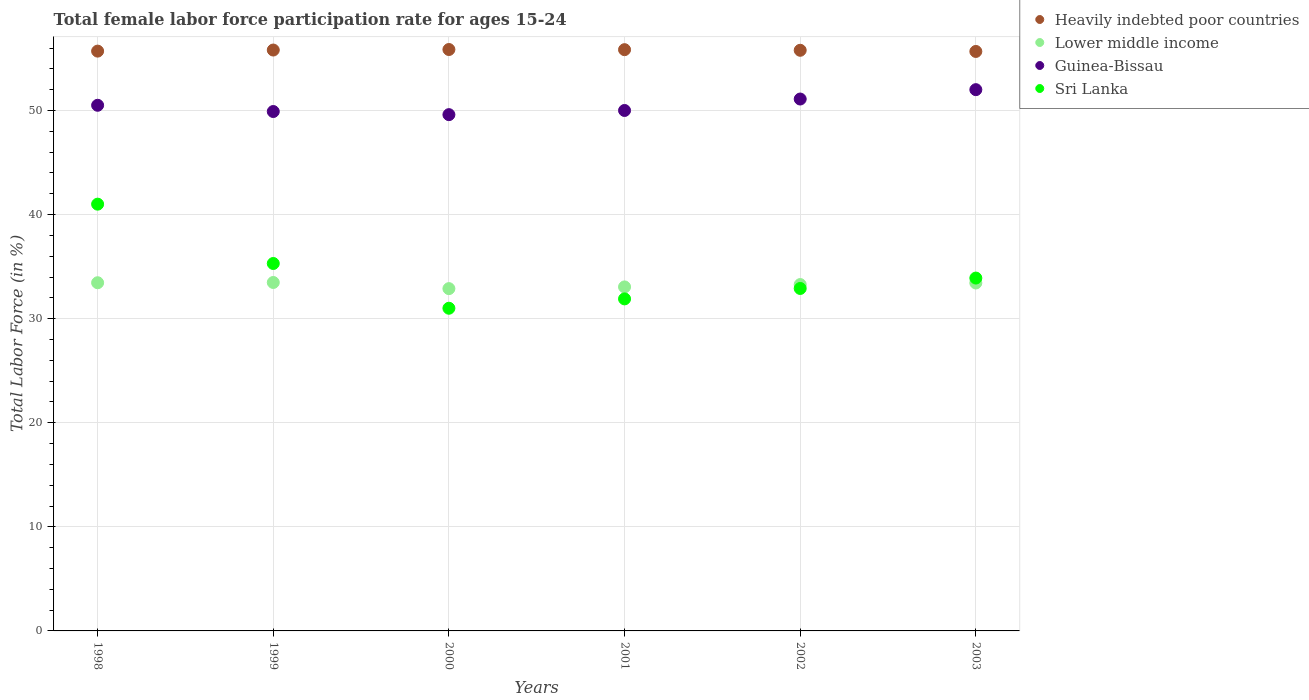Is the number of dotlines equal to the number of legend labels?
Your answer should be compact. Yes. Across all years, what is the maximum female labor force participation rate in Sri Lanka?
Your answer should be very brief. 41. Across all years, what is the minimum female labor force participation rate in Heavily indebted poor countries?
Your answer should be compact. 55.67. What is the total female labor force participation rate in Heavily indebted poor countries in the graph?
Make the answer very short. 334.66. What is the difference between the female labor force participation rate in Guinea-Bissau in 2000 and that in 2003?
Your response must be concise. -2.4. What is the difference between the female labor force participation rate in Sri Lanka in 1998 and the female labor force participation rate in Lower middle income in 2002?
Provide a short and direct response. 7.72. What is the average female labor force participation rate in Guinea-Bissau per year?
Offer a terse response. 50.52. In the year 2002, what is the difference between the female labor force participation rate in Guinea-Bissau and female labor force participation rate in Heavily indebted poor countries?
Offer a terse response. -4.68. In how many years, is the female labor force participation rate in Lower middle income greater than 52 %?
Provide a succinct answer. 0. What is the ratio of the female labor force participation rate in Sri Lanka in 1998 to that in 2001?
Make the answer very short. 1.29. Is the female labor force participation rate in Heavily indebted poor countries in 1998 less than that in 2000?
Provide a short and direct response. Yes. Is the difference between the female labor force participation rate in Guinea-Bissau in 1999 and 2003 greater than the difference between the female labor force participation rate in Heavily indebted poor countries in 1999 and 2003?
Ensure brevity in your answer.  No. What is the difference between the highest and the second highest female labor force participation rate in Heavily indebted poor countries?
Provide a succinct answer. 0.02. In how many years, is the female labor force participation rate in Guinea-Bissau greater than the average female labor force participation rate in Guinea-Bissau taken over all years?
Provide a short and direct response. 2. Is it the case that in every year, the sum of the female labor force participation rate in Lower middle income and female labor force participation rate in Sri Lanka  is greater than the female labor force participation rate in Guinea-Bissau?
Your answer should be very brief. Yes. Does the female labor force participation rate in Guinea-Bissau monotonically increase over the years?
Make the answer very short. No. Are the values on the major ticks of Y-axis written in scientific E-notation?
Provide a short and direct response. No. Does the graph contain grids?
Give a very brief answer. Yes. What is the title of the graph?
Offer a terse response. Total female labor force participation rate for ages 15-24. Does "Denmark" appear as one of the legend labels in the graph?
Your answer should be very brief. No. What is the label or title of the X-axis?
Offer a terse response. Years. What is the Total Labor Force (in %) of Heavily indebted poor countries in 1998?
Offer a terse response. 55.7. What is the Total Labor Force (in %) of Lower middle income in 1998?
Make the answer very short. 33.45. What is the Total Labor Force (in %) of Guinea-Bissau in 1998?
Keep it short and to the point. 50.5. What is the Total Labor Force (in %) of Sri Lanka in 1998?
Your response must be concise. 41. What is the Total Labor Force (in %) in Heavily indebted poor countries in 1999?
Ensure brevity in your answer.  55.81. What is the Total Labor Force (in %) of Lower middle income in 1999?
Offer a very short reply. 33.48. What is the Total Labor Force (in %) in Guinea-Bissau in 1999?
Your answer should be compact. 49.9. What is the Total Labor Force (in %) in Sri Lanka in 1999?
Offer a very short reply. 35.3. What is the Total Labor Force (in %) in Heavily indebted poor countries in 2000?
Make the answer very short. 55.86. What is the Total Labor Force (in %) in Lower middle income in 2000?
Keep it short and to the point. 32.89. What is the Total Labor Force (in %) of Guinea-Bissau in 2000?
Keep it short and to the point. 49.6. What is the Total Labor Force (in %) of Heavily indebted poor countries in 2001?
Offer a very short reply. 55.84. What is the Total Labor Force (in %) of Lower middle income in 2001?
Give a very brief answer. 33.05. What is the Total Labor Force (in %) of Sri Lanka in 2001?
Your response must be concise. 31.9. What is the Total Labor Force (in %) in Heavily indebted poor countries in 2002?
Your response must be concise. 55.78. What is the Total Labor Force (in %) of Lower middle income in 2002?
Provide a short and direct response. 33.28. What is the Total Labor Force (in %) of Guinea-Bissau in 2002?
Keep it short and to the point. 51.1. What is the Total Labor Force (in %) of Sri Lanka in 2002?
Make the answer very short. 32.9. What is the Total Labor Force (in %) in Heavily indebted poor countries in 2003?
Offer a very short reply. 55.67. What is the Total Labor Force (in %) of Lower middle income in 2003?
Offer a very short reply. 33.43. What is the Total Labor Force (in %) of Sri Lanka in 2003?
Provide a succinct answer. 33.9. Across all years, what is the maximum Total Labor Force (in %) of Heavily indebted poor countries?
Keep it short and to the point. 55.86. Across all years, what is the maximum Total Labor Force (in %) of Lower middle income?
Your answer should be very brief. 33.48. Across all years, what is the minimum Total Labor Force (in %) in Heavily indebted poor countries?
Give a very brief answer. 55.67. Across all years, what is the minimum Total Labor Force (in %) in Lower middle income?
Your answer should be very brief. 32.89. Across all years, what is the minimum Total Labor Force (in %) of Guinea-Bissau?
Ensure brevity in your answer.  49.6. What is the total Total Labor Force (in %) in Heavily indebted poor countries in the graph?
Your answer should be compact. 334.66. What is the total Total Labor Force (in %) in Lower middle income in the graph?
Make the answer very short. 199.56. What is the total Total Labor Force (in %) in Guinea-Bissau in the graph?
Your answer should be very brief. 303.1. What is the total Total Labor Force (in %) of Sri Lanka in the graph?
Make the answer very short. 206. What is the difference between the Total Labor Force (in %) of Heavily indebted poor countries in 1998 and that in 1999?
Your answer should be compact. -0.1. What is the difference between the Total Labor Force (in %) of Lower middle income in 1998 and that in 1999?
Your answer should be very brief. -0.02. What is the difference between the Total Labor Force (in %) of Sri Lanka in 1998 and that in 1999?
Give a very brief answer. 5.7. What is the difference between the Total Labor Force (in %) of Heavily indebted poor countries in 1998 and that in 2000?
Provide a succinct answer. -0.15. What is the difference between the Total Labor Force (in %) in Lower middle income in 1998 and that in 2000?
Your response must be concise. 0.56. What is the difference between the Total Labor Force (in %) of Sri Lanka in 1998 and that in 2000?
Your answer should be compact. 10. What is the difference between the Total Labor Force (in %) in Heavily indebted poor countries in 1998 and that in 2001?
Provide a succinct answer. -0.14. What is the difference between the Total Labor Force (in %) of Lower middle income in 1998 and that in 2001?
Your answer should be very brief. 0.4. What is the difference between the Total Labor Force (in %) of Heavily indebted poor countries in 1998 and that in 2002?
Ensure brevity in your answer.  -0.08. What is the difference between the Total Labor Force (in %) in Lower middle income in 1998 and that in 2002?
Your response must be concise. 0.17. What is the difference between the Total Labor Force (in %) in Sri Lanka in 1998 and that in 2002?
Keep it short and to the point. 8.1. What is the difference between the Total Labor Force (in %) in Heavily indebted poor countries in 1998 and that in 2003?
Offer a very short reply. 0.03. What is the difference between the Total Labor Force (in %) of Lower middle income in 1998 and that in 2003?
Offer a very short reply. 0.02. What is the difference between the Total Labor Force (in %) of Guinea-Bissau in 1998 and that in 2003?
Your answer should be very brief. -1.5. What is the difference between the Total Labor Force (in %) in Sri Lanka in 1998 and that in 2003?
Make the answer very short. 7.1. What is the difference between the Total Labor Force (in %) of Heavily indebted poor countries in 1999 and that in 2000?
Your answer should be very brief. -0.05. What is the difference between the Total Labor Force (in %) in Lower middle income in 1999 and that in 2000?
Your answer should be very brief. 0.59. What is the difference between the Total Labor Force (in %) of Heavily indebted poor countries in 1999 and that in 2001?
Give a very brief answer. -0.04. What is the difference between the Total Labor Force (in %) in Lower middle income in 1999 and that in 2001?
Offer a very short reply. 0.43. What is the difference between the Total Labor Force (in %) of Guinea-Bissau in 1999 and that in 2001?
Your answer should be compact. -0.1. What is the difference between the Total Labor Force (in %) in Heavily indebted poor countries in 1999 and that in 2002?
Your response must be concise. 0.02. What is the difference between the Total Labor Force (in %) of Lower middle income in 1999 and that in 2002?
Provide a succinct answer. 0.2. What is the difference between the Total Labor Force (in %) in Heavily indebted poor countries in 1999 and that in 2003?
Give a very brief answer. 0.14. What is the difference between the Total Labor Force (in %) of Lower middle income in 1999 and that in 2003?
Your answer should be compact. 0.05. What is the difference between the Total Labor Force (in %) in Guinea-Bissau in 1999 and that in 2003?
Keep it short and to the point. -2.1. What is the difference between the Total Labor Force (in %) in Heavily indebted poor countries in 2000 and that in 2001?
Give a very brief answer. 0.02. What is the difference between the Total Labor Force (in %) of Lower middle income in 2000 and that in 2001?
Ensure brevity in your answer.  -0.16. What is the difference between the Total Labor Force (in %) of Guinea-Bissau in 2000 and that in 2001?
Your response must be concise. -0.4. What is the difference between the Total Labor Force (in %) of Heavily indebted poor countries in 2000 and that in 2002?
Ensure brevity in your answer.  0.07. What is the difference between the Total Labor Force (in %) in Lower middle income in 2000 and that in 2002?
Make the answer very short. -0.39. What is the difference between the Total Labor Force (in %) in Heavily indebted poor countries in 2000 and that in 2003?
Provide a succinct answer. 0.19. What is the difference between the Total Labor Force (in %) of Lower middle income in 2000 and that in 2003?
Ensure brevity in your answer.  -0.54. What is the difference between the Total Labor Force (in %) in Heavily indebted poor countries in 2001 and that in 2002?
Give a very brief answer. 0.06. What is the difference between the Total Labor Force (in %) of Lower middle income in 2001 and that in 2002?
Give a very brief answer. -0.23. What is the difference between the Total Labor Force (in %) in Guinea-Bissau in 2001 and that in 2002?
Your response must be concise. -1.1. What is the difference between the Total Labor Force (in %) of Sri Lanka in 2001 and that in 2002?
Make the answer very short. -1. What is the difference between the Total Labor Force (in %) of Heavily indebted poor countries in 2001 and that in 2003?
Ensure brevity in your answer.  0.17. What is the difference between the Total Labor Force (in %) of Lower middle income in 2001 and that in 2003?
Provide a short and direct response. -0.38. What is the difference between the Total Labor Force (in %) in Heavily indebted poor countries in 2002 and that in 2003?
Your answer should be very brief. 0.11. What is the difference between the Total Labor Force (in %) in Lower middle income in 2002 and that in 2003?
Provide a succinct answer. -0.15. What is the difference between the Total Labor Force (in %) in Heavily indebted poor countries in 1998 and the Total Labor Force (in %) in Lower middle income in 1999?
Give a very brief answer. 22.23. What is the difference between the Total Labor Force (in %) in Heavily indebted poor countries in 1998 and the Total Labor Force (in %) in Guinea-Bissau in 1999?
Give a very brief answer. 5.8. What is the difference between the Total Labor Force (in %) of Heavily indebted poor countries in 1998 and the Total Labor Force (in %) of Sri Lanka in 1999?
Keep it short and to the point. 20.4. What is the difference between the Total Labor Force (in %) in Lower middle income in 1998 and the Total Labor Force (in %) in Guinea-Bissau in 1999?
Your response must be concise. -16.45. What is the difference between the Total Labor Force (in %) in Lower middle income in 1998 and the Total Labor Force (in %) in Sri Lanka in 1999?
Provide a succinct answer. -1.85. What is the difference between the Total Labor Force (in %) in Heavily indebted poor countries in 1998 and the Total Labor Force (in %) in Lower middle income in 2000?
Give a very brief answer. 22.82. What is the difference between the Total Labor Force (in %) in Heavily indebted poor countries in 1998 and the Total Labor Force (in %) in Guinea-Bissau in 2000?
Offer a terse response. 6.1. What is the difference between the Total Labor Force (in %) of Heavily indebted poor countries in 1998 and the Total Labor Force (in %) of Sri Lanka in 2000?
Offer a very short reply. 24.7. What is the difference between the Total Labor Force (in %) in Lower middle income in 1998 and the Total Labor Force (in %) in Guinea-Bissau in 2000?
Your answer should be compact. -16.15. What is the difference between the Total Labor Force (in %) of Lower middle income in 1998 and the Total Labor Force (in %) of Sri Lanka in 2000?
Offer a very short reply. 2.45. What is the difference between the Total Labor Force (in %) in Heavily indebted poor countries in 1998 and the Total Labor Force (in %) in Lower middle income in 2001?
Provide a succinct answer. 22.65. What is the difference between the Total Labor Force (in %) in Heavily indebted poor countries in 1998 and the Total Labor Force (in %) in Guinea-Bissau in 2001?
Your answer should be compact. 5.7. What is the difference between the Total Labor Force (in %) of Heavily indebted poor countries in 1998 and the Total Labor Force (in %) of Sri Lanka in 2001?
Your response must be concise. 23.8. What is the difference between the Total Labor Force (in %) of Lower middle income in 1998 and the Total Labor Force (in %) of Guinea-Bissau in 2001?
Offer a very short reply. -16.55. What is the difference between the Total Labor Force (in %) in Lower middle income in 1998 and the Total Labor Force (in %) in Sri Lanka in 2001?
Provide a succinct answer. 1.55. What is the difference between the Total Labor Force (in %) of Guinea-Bissau in 1998 and the Total Labor Force (in %) of Sri Lanka in 2001?
Your answer should be compact. 18.6. What is the difference between the Total Labor Force (in %) of Heavily indebted poor countries in 1998 and the Total Labor Force (in %) of Lower middle income in 2002?
Offer a very short reply. 22.43. What is the difference between the Total Labor Force (in %) of Heavily indebted poor countries in 1998 and the Total Labor Force (in %) of Guinea-Bissau in 2002?
Provide a short and direct response. 4.6. What is the difference between the Total Labor Force (in %) in Heavily indebted poor countries in 1998 and the Total Labor Force (in %) in Sri Lanka in 2002?
Offer a terse response. 22.8. What is the difference between the Total Labor Force (in %) of Lower middle income in 1998 and the Total Labor Force (in %) of Guinea-Bissau in 2002?
Keep it short and to the point. -17.65. What is the difference between the Total Labor Force (in %) of Lower middle income in 1998 and the Total Labor Force (in %) of Sri Lanka in 2002?
Provide a succinct answer. 0.55. What is the difference between the Total Labor Force (in %) in Heavily indebted poor countries in 1998 and the Total Labor Force (in %) in Lower middle income in 2003?
Make the answer very short. 22.27. What is the difference between the Total Labor Force (in %) in Heavily indebted poor countries in 1998 and the Total Labor Force (in %) in Guinea-Bissau in 2003?
Make the answer very short. 3.7. What is the difference between the Total Labor Force (in %) of Heavily indebted poor countries in 1998 and the Total Labor Force (in %) of Sri Lanka in 2003?
Provide a succinct answer. 21.8. What is the difference between the Total Labor Force (in %) of Lower middle income in 1998 and the Total Labor Force (in %) of Guinea-Bissau in 2003?
Provide a short and direct response. -18.55. What is the difference between the Total Labor Force (in %) in Lower middle income in 1998 and the Total Labor Force (in %) in Sri Lanka in 2003?
Provide a succinct answer. -0.45. What is the difference between the Total Labor Force (in %) of Guinea-Bissau in 1998 and the Total Labor Force (in %) of Sri Lanka in 2003?
Provide a succinct answer. 16.6. What is the difference between the Total Labor Force (in %) of Heavily indebted poor countries in 1999 and the Total Labor Force (in %) of Lower middle income in 2000?
Offer a very short reply. 22.92. What is the difference between the Total Labor Force (in %) of Heavily indebted poor countries in 1999 and the Total Labor Force (in %) of Guinea-Bissau in 2000?
Provide a succinct answer. 6.21. What is the difference between the Total Labor Force (in %) of Heavily indebted poor countries in 1999 and the Total Labor Force (in %) of Sri Lanka in 2000?
Provide a succinct answer. 24.81. What is the difference between the Total Labor Force (in %) in Lower middle income in 1999 and the Total Labor Force (in %) in Guinea-Bissau in 2000?
Provide a short and direct response. -16.12. What is the difference between the Total Labor Force (in %) of Lower middle income in 1999 and the Total Labor Force (in %) of Sri Lanka in 2000?
Ensure brevity in your answer.  2.48. What is the difference between the Total Labor Force (in %) of Heavily indebted poor countries in 1999 and the Total Labor Force (in %) of Lower middle income in 2001?
Make the answer very short. 22.76. What is the difference between the Total Labor Force (in %) in Heavily indebted poor countries in 1999 and the Total Labor Force (in %) in Guinea-Bissau in 2001?
Offer a terse response. 5.81. What is the difference between the Total Labor Force (in %) in Heavily indebted poor countries in 1999 and the Total Labor Force (in %) in Sri Lanka in 2001?
Your answer should be compact. 23.91. What is the difference between the Total Labor Force (in %) of Lower middle income in 1999 and the Total Labor Force (in %) of Guinea-Bissau in 2001?
Your answer should be compact. -16.52. What is the difference between the Total Labor Force (in %) of Lower middle income in 1999 and the Total Labor Force (in %) of Sri Lanka in 2001?
Make the answer very short. 1.58. What is the difference between the Total Labor Force (in %) of Heavily indebted poor countries in 1999 and the Total Labor Force (in %) of Lower middle income in 2002?
Ensure brevity in your answer.  22.53. What is the difference between the Total Labor Force (in %) of Heavily indebted poor countries in 1999 and the Total Labor Force (in %) of Guinea-Bissau in 2002?
Ensure brevity in your answer.  4.71. What is the difference between the Total Labor Force (in %) of Heavily indebted poor countries in 1999 and the Total Labor Force (in %) of Sri Lanka in 2002?
Keep it short and to the point. 22.91. What is the difference between the Total Labor Force (in %) of Lower middle income in 1999 and the Total Labor Force (in %) of Guinea-Bissau in 2002?
Your response must be concise. -17.62. What is the difference between the Total Labor Force (in %) in Lower middle income in 1999 and the Total Labor Force (in %) in Sri Lanka in 2002?
Offer a terse response. 0.58. What is the difference between the Total Labor Force (in %) in Heavily indebted poor countries in 1999 and the Total Labor Force (in %) in Lower middle income in 2003?
Your answer should be very brief. 22.38. What is the difference between the Total Labor Force (in %) of Heavily indebted poor countries in 1999 and the Total Labor Force (in %) of Guinea-Bissau in 2003?
Give a very brief answer. 3.81. What is the difference between the Total Labor Force (in %) in Heavily indebted poor countries in 1999 and the Total Labor Force (in %) in Sri Lanka in 2003?
Ensure brevity in your answer.  21.91. What is the difference between the Total Labor Force (in %) of Lower middle income in 1999 and the Total Labor Force (in %) of Guinea-Bissau in 2003?
Your response must be concise. -18.52. What is the difference between the Total Labor Force (in %) in Lower middle income in 1999 and the Total Labor Force (in %) in Sri Lanka in 2003?
Keep it short and to the point. -0.42. What is the difference between the Total Labor Force (in %) in Heavily indebted poor countries in 2000 and the Total Labor Force (in %) in Lower middle income in 2001?
Your answer should be very brief. 22.81. What is the difference between the Total Labor Force (in %) in Heavily indebted poor countries in 2000 and the Total Labor Force (in %) in Guinea-Bissau in 2001?
Offer a terse response. 5.86. What is the difference between the Total Labor Force (in %) in Heavily indebted poor countries in 2000 and the Total Labor Force (in %) in Sri Lanka in 2001?
Your response must be concise. 23.96. What is the difference between the Total Labor Force (in %) of Lower middle income in 2000 and the Total Labor Force (in %) of Guinea-Bissau in 2001?
Provide a short and direct response. -17.11. What is the difference between the Total Labor Force (in %) of Lower middle income in 2000 and the Total Labor Force (in %) of Sri Lanka in 2001?
Make the answer very short. 0.99. What is the difference between the Total Labor Force (in %) in Guinea-Bissau in 2000 and the Total Labor Force (in %) in Sri Lanka in 2001?
Ensure brevity in your answer.  17.7. What is the difference between the Total Labor Force (in %) in Heavily indebted poor countries in 2000 and the Total Labor Force (in %) in Lower middle income in 2002?
Give a very brief answer. 22.58. What is the difference between the Total Labor Force (in %) of Heavily indebted poor countries in 2000 and the Total Labor Force (in %) of Guinea-Bissau in 2002?
Keep it short and to the point. 4.76. What is the difference between the Total Labor Force (in %) in Heavily indebted poor countries in 2000 and the Total Labor Force (in %) in Sri Lanka in 2002?
Your answer should be very brief. 22.96. What is the difference between the Total Labor Force (in %) of Lower middle income in 2000 and the Total Labor Force (in %) of Guinea-Bissau in 2002?
Provide a short and direct response. -18.21. What is the difference between the Total Labor Force (in %) of Lower middle income in 2000 and the Total Labor Force (in %) of Sri Lanka in 2002?
Your response must be concise. -0.01. What is the difference between the Total Labor Force (in %) of Guinea-Bissau in 2000 and the Total Labor Force (in %) of Sri Lanka in 2002?
Keep it short and to the point. 16.7. What is the difference between the Total Labor Force (in %) in Heavily indebted poor countries in 2000 and the Total Labor Force (in %) in Lower middle income in 2003?
Offer a terse response. 22.43. What is the difference between the Total Labor Force (in %) in Heavily indebted poor countries in 2000 and the Total Labor Force (in %) in Guinea-Bissau in 2003?
Provide a succinct answer. 3.86. What is the difference between the Total Labor Force (in %) in Heavily indebted poor countries in 2000 and the Total Labor Force (in %) in Sri Lanka in 2003?
Ensure brevity in your answer.  21.96. What is the difference between the Total Labor Force (in %) in Lower middle income in 2000 and the Total Labor Force (in %) in Guinea-Bissau in 2003?
Provide a succinct answer. -19.11. What is the difference between the Total Labor Force (in %) in Lower middle income in 2000 and the Total Labor Force (in %) in Sri Lanka in 2003?
Offer a terse response. -1.01. What is the difference between the Total Labor Force (in %) of Heavily indebted poor countries in 2001 and the Total Labor Force (in %) of Lower middle income in 2002?
Make the answer very short. 22.57. What is the difference between the Total Labor Force (in %) of Heavily indebted poor countries in 2001 and the Total Labor Force (in %) of Guinea-Bissau in 2002?
Provide a short and direct response. 4.74. What is the difference between the Total Labor Force (in %) in Heavily indebted poor countries in 2001 and the Total Labor Force (in %) in Sri Lanka in 2002?
Your answer should be very brief. 22.94. What is the difference between the Total Labor Force (in %) of Lower middle income in 2001 and the Total Labor Force (in %) of Guinea-Bissau in 2002?
Offer a terse response. -18.05. What is the difference between the Total Labor Force (in %) of Lower middle income in 2001 and the Total Labor Force (in %) of Sri Lanka in 2002?
Make the answer very short. 0.15. What is the difference between the Total Labor Force (in %) in Heavily indebted poor countries in 2001 and the Total Labor Force (in %) in Lower middle income in 2003?
Ensure brevity in your answer.  22.41. What is the difference between the Total Labor Force (in %) of Heavily indebted poor countries in 2001 and the Total Labor Force (in %) of Guinea-Bissau in 2003?
Your answer should be compact. 3.84. What is the difference between the Total Labor Force (in %) of Heavily indebted poor countries in 2001 and the Total Labor Force (in %) of Sri Lanka in 2003?
Your answer should be compact. 21.94. What is the difference between the Total Labor Force (in %) of Lower middle income in 2001 and the Total Labor Force (in %) of Guinea-Bissau in 2003?
Provide a short and direct response. -18.95. What is the difference between the Total Labor Force (in %) in Lower middle income in 2001 and the Total Labor Force (in %) in Sri Lanka in 2003?
Keep it short and to the point. -0.85. What is the difference between the Total Labor Force (in %) of Heavily indebted poor countries in 2002 and the Total Labor Force (in %) of Lower middle income in 2003?
Your response must be concise. 22.35. What is the difference between the Total Labor Force (in %) in Heavily indebted poor countries in 2002 and the Total Labor Force (in %) in Guinea-Bissau in 2003?
Offer a very short reply. 3.78. What is the difference between the Total Labor Force (in %) in Heavily indebted poor countries in 2002 and the Total Labor Force (in %) in Sri Lanka in 2003?
Offer a terse response. 21.88. What is the difference between the Total Labor Force (in %) of Lower middle income in 2002 and the Total Labor Force (in %) of Guinea-Bissau in 2003?
Give a very brief answer. -18.72. What is the difference between the Total Labor Force (in %) in Lower middle income in 2002 and the Total Labor Force (in %) in Sri Lanka in 2003?
Make the answer very short. -0.62. What is the difference between the Total Labor Force (in %) in Guinea-Bissau in 2002 and the Total Labor Force (in %) in Sri Lanka in 2003?
Provide a short and direct response. 17.2. What is the average Total Labor Force (in %) in Heavily indebted poor countries per year?
Ensure brevity in your answer.  55.78. What is the average Total Labor Force (in %) of Lower middle income per year?
Your response must be concise. 33.26. What is the average Total Labor Force (in %) of Guinea-Bissau per year?
Your answer should be compact. 50.52. What is the average Total Labor Force (in %) in Sri Lanka per year?
Offer a terse response. 34.33. In the year 1998, what is the difference between the Total Labor Force (in %) of Heavily indebted poor countries and Total Labor Force (in %) of Lower middle income?
Give a very brief answer. 22.25. In the year 1998, what is the difference between the Total Labor Force (in %) of Heavily indebted poor countries and Total Labor Force (in %) of Guinea-Bissau?
Your answer should be compact. 5.2. In the year 1998, what is the difference between the Total Labor Force (in %) of Heavily indebted poor countries and Total Labor Force (in %) of Sri Lanka?
Give a very brief answer. 14.7. In the year 1998, what is the difference between the Total Labor Force (in %) in Lower middle income and Total Labor Force (in %) in Guinea-Bissau?
Give a very brief answer. -17.05. In the year 1998, what is the difference between the Total Labor Force (in %) of Lower middle income and Total Labor Force (in %) of Sri Lanka?
Your answer should be very brief. -7.55. In the year 1998, what is the difference between the Total Labor Force (in %) of Guinea-Bissau and Total Labor Force (in %) of Sri Lanka?
Ensure brevity in your answer.  9.5. In the year 1999, what is the difference between the Total Labor Force (in %) of Heavily indebted poor countries and Total Labor Force (in %) of Lower middle income?
Your response must be concise. 22.33. In the year 1999, what is the difference between the Total Labor Force (in %) of Heavily indebted poor countries and Total Labor Force (in %) of Guinea-Bissau?
Offer a very short reply. 5.91. In the year 1999, what is the difference between the Total Labor Force (in %) of Heavily indebted poor countries and Total Labor Force (in %) of Sri Lanka?
Make the answer very short. 20.51. In the year 1999, what is the difference between the Total Labor Force (in %) in Lower middle income and Total Labor Force (in %) in Guinea-Bissau?
Provide a succinct answer. -16.42. In the year 1999, what is the difference between the Total Labor Force (in %) of Lower middle income and Total Labor Force (in %) of Sri Lanka?
Keep it short and to the point. -1.82. In the year 1999, what is the difference between the Total Labor Force (in %) in Guinea-Bissau and Total Labor Force (in %) in Sri Lanka?
Offer a terse response. 14.6. In the year 2000, what is the difference between the Total Labor Force (in %) in Heavily indebted poor countries and Total Labor Force (in %) in Lower middle income?
Your answer should be very brief. 22.97. In the year 2000, what is the difference between the Total Labor Force (in %) in Heavily indebted poor countries and Total Labor Force (in %) in Guinea-Bissau?
Your response must be concise. 6.26. In the year 2000, what is the difference between the Total Labor Force (in %) of Heavily indebted poor countries and Total Labor Force (in %) of Sri Lanka?
Give a very brief answer. 24.86. In the year 2000, what is the difference between the Total Labor Force (in %) in Lower middle income and Total Labor Force (in %) in Guinea-Bissau?
Offer a very short reply. -16.71. In the year 2000, what is the difference between the Total Labor Force (in %) of Lower middle income and Total Labor Force (in %) of Sri Lanka?
Provide a short and direct response. 1.89. In the year 2001, what is the difference between the Total Labor Force (in %) in Heavily indebted poor countries and Total Labor Force (in %) in Lower middle income?
Your answer should be very brief. 22.79. In the year 2001, what is the difference between the Total Labor Force (in %) in Heavily indebted poor countries and Total Labor Force (in %) in Guinea-Bissau?
Keep it short and to the point. 5.84. In the year 2001, what is the difference between the Total Labor Force (in %) of Heavily indebted poor countries and Total Labor Force (in %) of Sri Lanka?
Give a very brief answer. 23.94. In the year 2001, what is the difference between the Total Labor Force (in %) of Lower middle income and Total Labor Force (in %) of Guinea-Bissau?
Your answer should be compact. -16.95. In the year 2001, what is the difference between the Total Labor Force (in %) of Lower middle income and Total Labor Force (in %) of Sri Lanka?
Keep it short and to the point. 1.15. In the year 2001, what is the difference between the Total Labor Force (in %) in Guinea-Bissau and Total Labor Force (in %) in Sri Lanka?
Ensure brevity in your answer.  18.1. In the year 2002, what is the difference between the Total Labor Force (in %) of Heavily indebted poor countries and Total Labor Force (in %) of Lower middle income?
Your response must be concise. 22.51. In the year 2002, what is the difference between the Total Labor Force (in %) in Heavily indebted poor countries and Total Labor Force (in %) in Guinea-Bissau?
Ensure brevity in your answer.  4.68. In the year 2002, what is the difference between the Total Labor Force (in %) in Heavily indebted poor countries and Total Labor Force (in %) in Sri Lanka?
Give a very brief answer. 22.88. In the year 2002, what is the difference between the Total Labor Force (in %) of Lower middle income and Total Labor Force (in %) of Guinea-Bissau?
Ensure brevity in your answer.  -17.82. In the year 2002, what is the difference between the Total Labor Force (in %) in Lower middle income and Total Labor Force (in %) in Sri Lanka?
Provide a short and direct response. 0.38. In the year 2003, what is the difference between the Total Labor Force (in %) of Heavily indebted poor countries and Total Labor Force (in %) of Lower middle income?
Give a very brief answer. 22.24. In the year 2003, what is the difference between the Total Labor Force (in %) of Heavily indebted poor countries and Total Labor Force (in %) of Guinea-Bissau?
Offer a very short reply. 3.67. In the year 2003, what is the difference between the Total Labor Force (in %) in Heavily indebted poor countries and Total Labor Force (in %) in Sri Lanka?
Offer a terse response. 21.77. In the year 2003, what is the difference between the Total Labor Force (in %) in Lower middle income and Total Labor Force (in %) in Guinea-Bissau?
Offer a terse response. -18.57. In the year 2003, what is the difference between the Total Labor Force (in %) of Lower middle income and Total Labor Force (in %) of Sri Lanka?
Your response must be concise. -0.47. What is the ratio of the Total Labor Force (in %) of Lower middle income in 1998 to that in 1999?
Your answer should be very brief. 1. What is the ratio of the Total Labor Force (in %) of Guinea-Bissau in 1998 to that in 1999?
Your response must be concise. 1.01. What is the ratio of the Total Labor Force (in %) of Sri Lanka in 1998 to that in 1999?
Your answer should be compact. 1.16. What is the ratio of the Total Labor Force (in %) of Lower middle income in 1998 to that in 2000?
Your answer should be compact. 1.02. What is the ratio of the Total Labor Force (in %) in Guinea-Bissau in 1998 to that in 2000?
Ensure brevity in your answer.  1.02. What is the ratio of the Total Labor Force (in %) of Sri Lanka in 1998 to that in 2000?
Make the answer very short. 1.32. What is the ratio of the Total Labor Force (in %) of Lower middle income in 1998 to that in 2001?
Make the answer very short. 1.01. What is the ratio of the Total Labor Force (in %) in Sri Lanka in 1998 to that in 2001?
Keep it short and to the point. 1.29. What is the ratio of the Total Labor Force (in %) of Heavily indebted poor countries in 1998 to that in 2002?
Provide a succinct answer. 1. What is the ratio of the Total Labor Force (in %) in Guinea-Bissau in 1998 to that in 2002?
Your response must be concise. 0.99. What is the ratio of the Total Labor Force (in %) of Sri Lanka in 1998 to that in 2002?
Your answer should be compact. 1.25. What is the ratio of the Total Labor Force (in %) of Heavily indebted poor countries in 1998 to that in 2003?
Keep it short and to the point. 1. What is the ratio of the Total Labor Force (in %) in Lower middle income in 1998 to that in 2003?
Provide a succinct answer. 1. What is the ratio of the Total Labor Force (in %) of Guinea-Bissau in 1998 to that in 2003?
Keep it short and to the point. 0.97. What is the ratio of the Total Labor Force (in %) of Sri Lanka in 1998 to that in 2003?
Give a very brief answer. 1.21. What is the ratio of the Total Labor Force (in %) of Lower middle income in 1999 to that in 2000?
Keep it short and to the point. 1.02. What is the ratio of the Total Labor Force (in %) in Guinea-Bissau in 1999 to that in 2000?
Give a very brief answer. 1.01. What is the ratio of the Total Labor Force (in %) of Sri Lanka in 1999 to that in 2000?
Provide a short and direct response. 1.14. What is the ratio of the Total Labor Force (in %) in Lower middle income in 1999 to that in 2001?
Your answer should be very brief. 1.01. What is the ratio of the Total Labor Force (in %) of Guinea-Bissau in 1999 to that in 2001?
Ensure brevity in your answer.  1. What is the ratio of the Total Labor Force (in %) in Sri Lanka in 1999 to that in 2001?
Keep it short and to the point. 1.11. What is the ratio of the Total Labor Force (in %) of Guinea-Bissau in 1999 to that in 2002?
Provide a succinct answer. 0.98. What is the ratio of the Total Labor Force (in %) of Sri Lanka in 1999 to that in 2002?
Make the answer very short. 1.07. What is the ratio of the Total Labor Force (in %) of Lower middle income in 1999 to that in 2003?
Your answer should be very brief. 1. What is the ratio of the Total Labor Force (in %) in Guinea-Bissau in 1999 to that in 2003?
Give a very brief answer. 0.96. What is the ratio of the Total Labor Force (in %) of Sri Lanka in 1999 to that in 2003?
Offer a very short reply. 1.04. What is the ratio of the Total Labor Force (in %) of Lower middle income in 2000 to that in 2001?
Provide a short and direct response. 0.99. What is the ratio of the Total Labor Force (in %) of Guinea-Bissau in 2000 to that in 2001?
Ensure brevity in your answer.  0.99. What is the ratio of the Total Labor Force (in %) of Sri Lanka in 2000 to that in 2001?
Your response must be concise. 0.97. What is the ratio of the Total Labor Force (in %) of Heavily indebted poor countries in 2000 to that in 2002?
Offer a very short reply. 1. What is the ratio of the Total Labor Force (in %) in Lower middle income in 2000 to that in 2002?
Ensure brevity in your answer.  0.99. What is the ratio of the Total Labor Force (in %) of Guinea-Bissau in 2000 to that in 2002?
Give a very brief answer. 0.97. What is the ratio of the Total Labor Force (in %) of Sri Lanka in 2000 to that in 2002?
Give a very brief answer. 0.94. What is the ratio of the Total Labor Force (in %) in Lower middle income in 2000 to that in 2003?
Provide a short and direct response. 0.98. What is the ratio of the Total Labor Force (in %) of Guinea-Bissau in 2000 to that in 2003?
Offer a terse response. 0.95. What is the ratio of the Total Labor Force (in %) in Sri Lanka in 2000 to that in 2003?
Offer a terse response. 0.91. What is the ratio of the Total Labor Force (in %) of Lower middle income in 2001 to that in 2002?
Offer a very short reply. 0.99. What is the ratio of the Total Labor Force (in %) in Guinea-Bissau in 2001 to that in 2002?
Offer a terse response. 0.98. What is the ratio of the Total Labor Force (in %) in Sri Lanka in 2001 to that in 2002?
Keep it short and to the point. 0.97. What is the ratio of the Total Labor Force (in %) of Lower middle income in 2001 to that in 2003?
Keep it short and to the point. 0.99. What is the ratio of the Total Labor Force (in %) in Guinea-Bissau in 2001 to that in 2003?
Provide a short and direct response. 0.96. What is the ratio of the Total Labor Force (in %) of Sri Lanka in 2001 to that in 2003?
Provide a succinct answer. 0.94. What is the ratio of the Total Labor Force (in %) of Heavily indebted poor countries in 2002 to that in 2003?
Give a very brief answer. 1. What is the ratio of the Total Labor Force (in %) in Guinea-Bissau in 2002 to that in 2003?
Offer a terse response. 0.98. What is the ratio of the Total Labor Force (in %) in Sri Lanka in 2002 to that in 2003?
Ensure brevity in your answer.  0.97. What is the difference between the highest and the second highest Total Labor Force (in %) in Heavily indebted poor countries?
Your response must be concise. 0.02. What is the difference between the highest and the second highest Total Labor Force (in %) of Lower middle income?
Ensure brevity in your answer.  0.02. What is the difference between the highest and the lowest Total Labor Force (in %) in Heavily indebted poor countries?
Make the answer very short. 0.19. What is the difference between the highest and the lowest Total Labor Force (in %) in Lower middle income?
Your response must be concise. 0.59. 